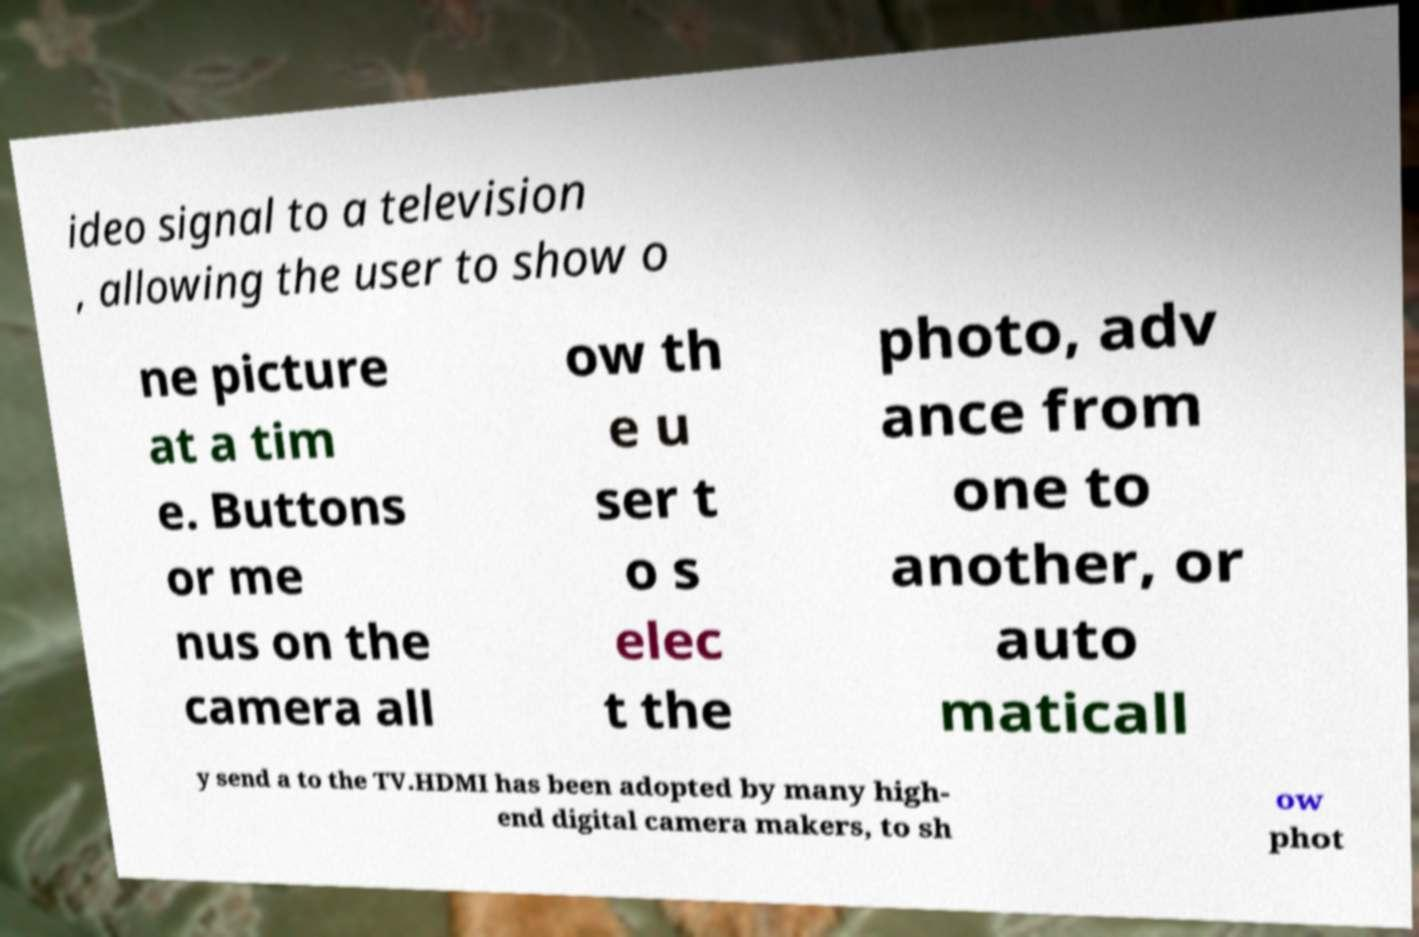Could you extract and type out the text from this image? ideo signal to a television , allowing the user to show o ne picture at a tim e. Buttons or me nus on the camera all ow th e u ser t o s elec t the photo, adv ance from one to another, or auto maticall y send a to the TV.HDMI has been adopted by many high- end digital camera makers, to sh ow phot 